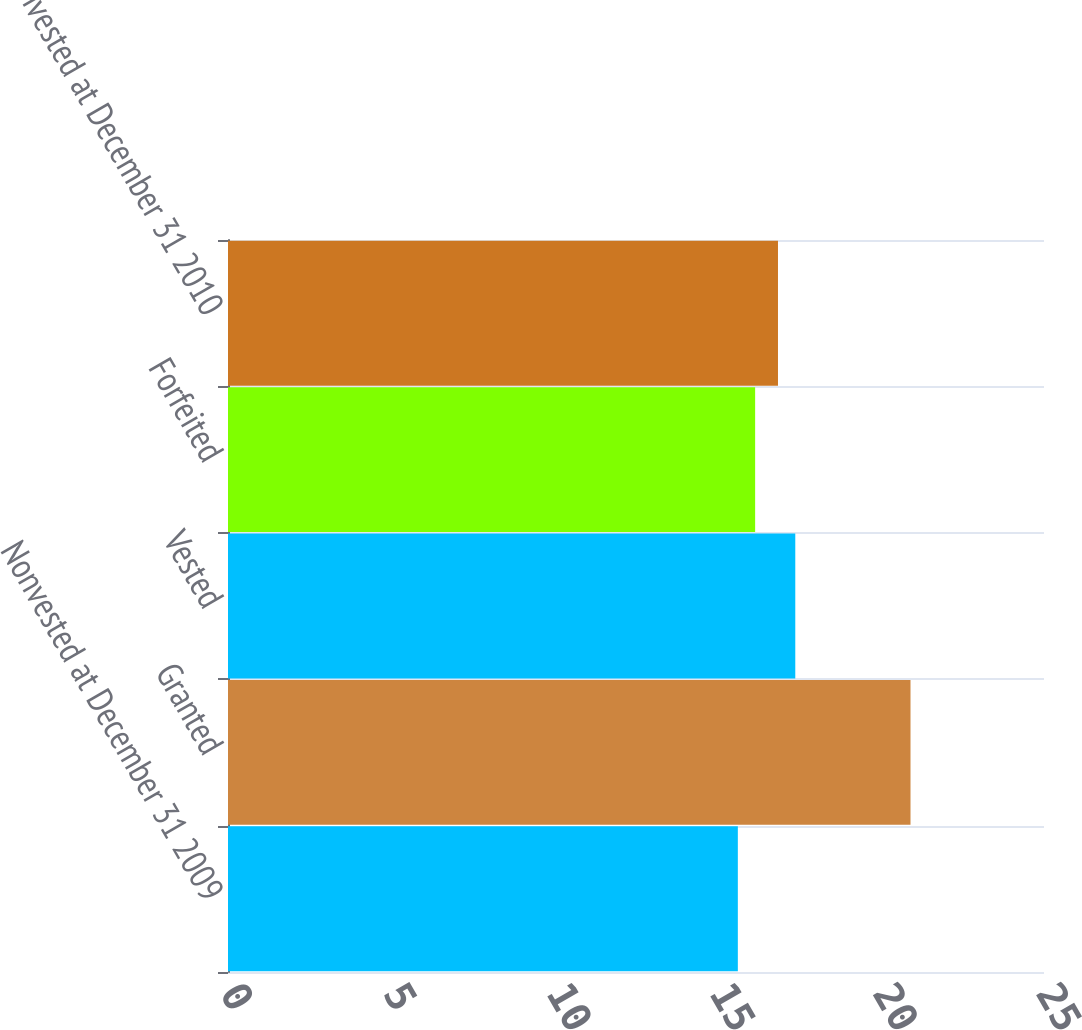Convert chart to OTSL. <chart><loc_0><loc_0><loc_500><loc_500><bar_chart><fcel>Nonvested at December 31 2009<fcel>Granted<fcel>Vested<fcel>Forfeited<fcel>Nonvested at December 31 2010<nl><fcel>15.62<fcel>20.91<fcel>17.38<fcel>16.15<fcel>16.85<nl></chart> 